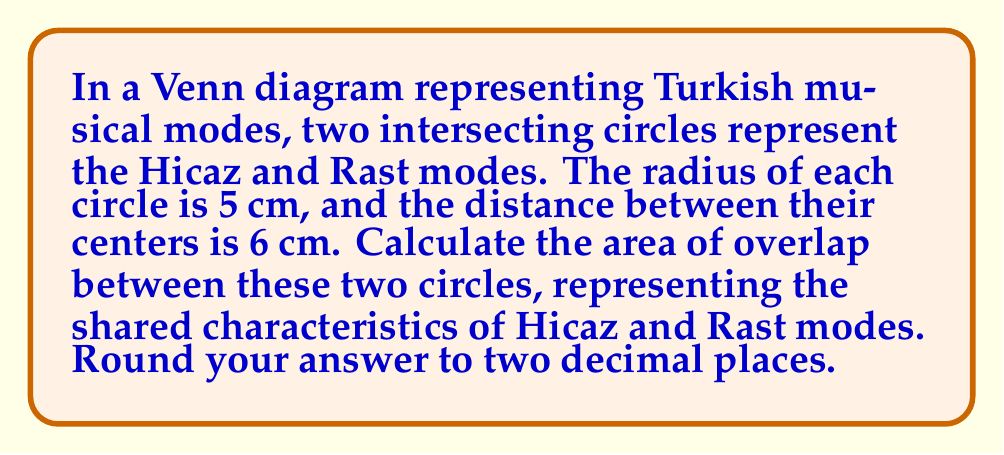Show me your answer to this math problem. Let's approach this step-by-step:

1) First, we need to recall the formula for the area of overlap between two circles:

   $$A = 2r^2 \arccos(\frac{d}{2r}) - d\sqrt{r^2 - \frac{d^2}{4}}$$

   Where $r$ is the radius of each circle and $d$ is the distance between their centers.

2) We're given:
   $r = 5$ cm
   $d = 6$ cm

3) Let's substitute these values into our formula:

   $$A = 2(5^2) \arccos(\frac{6}{2(5)}) - 6\sqrt{5^2 - \frac{6^2}{4}}$$

4) Simplify inside the arccos:
   $$A = 2(25) \arccos(\frac{3}{5}) - 6\sqrt{25 - 9}$$

5) Simplify under the square root:
   $$A = 50 \arccos(0.6) - 6\sqrt{16}$$

6) Calculate the square root:
   $$A = 50 \arccos(0.6) - 6(4)$$

7) Multiply:
   $$A = 50 \arccos(0.6) - 24$$

8) Use a calculator to compute arccos(0.6) ≈ 0.9273 radians:
   $$A ≈ 50(0.9273) - 24$$

9) Multiply:
   $$A ≈ 46.365 - 24 = 22.365$$

10) Rounding to two decimal places:
    $$A ≈ 22.37 \text{ cm}^2$$

[asy]
import geometry;

pair O1 = (0,0), O2 = (6,0);
real r = 5;

draw(circle(O1,r));
draw(circle(O2,r));
draw(O1--O2);

label("Hicaz", (-4,0));
label("Rast", (10,0));
label("5 cm", (0,-5.5));
label("5 cm", (6,-5.5));
label("6 cm", (3,0.5));

[/asy]
Answer: $22.37 \text{ cm}^2$ 